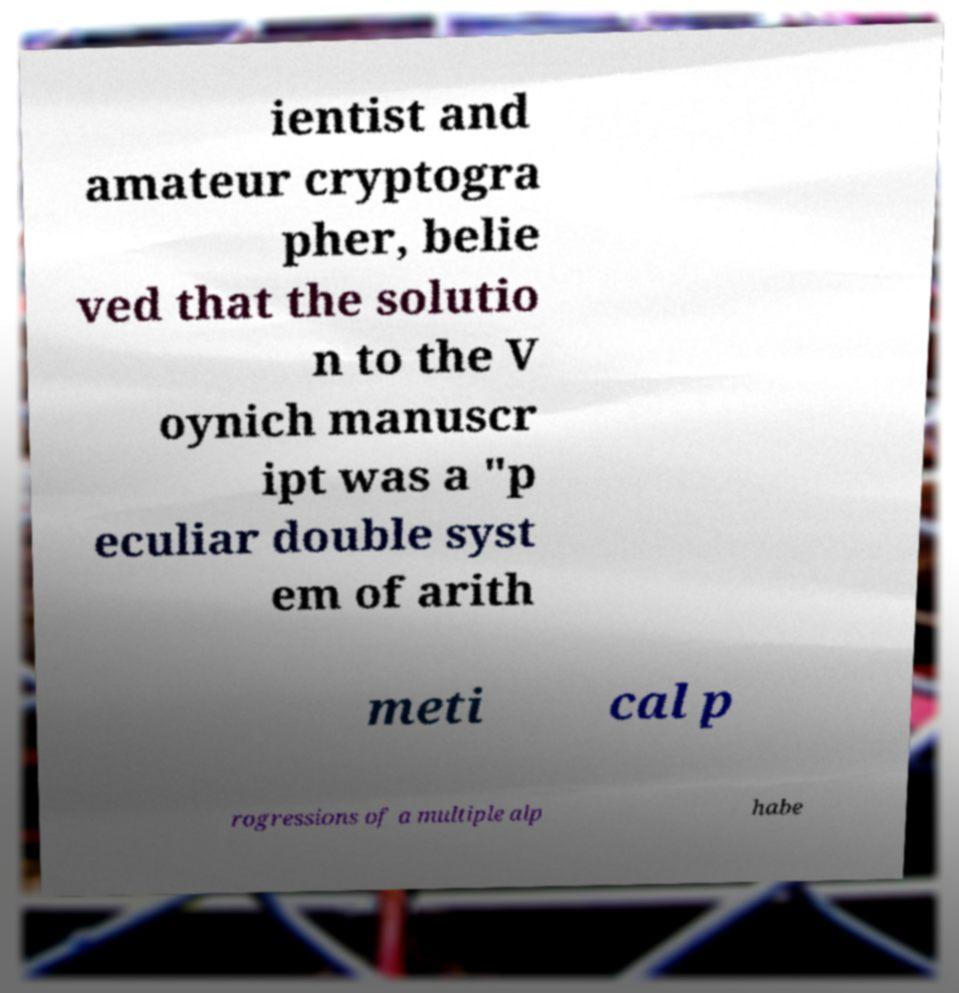Could you assist in decoding the text presented in this image and type it out clearly? ientist and amateur cryptogra pher, belie ved that the solutio n to the V oynich manuscr ipt was a "p eculiar double syst em of arith meti cal p rogressions of a multiple alp habe 